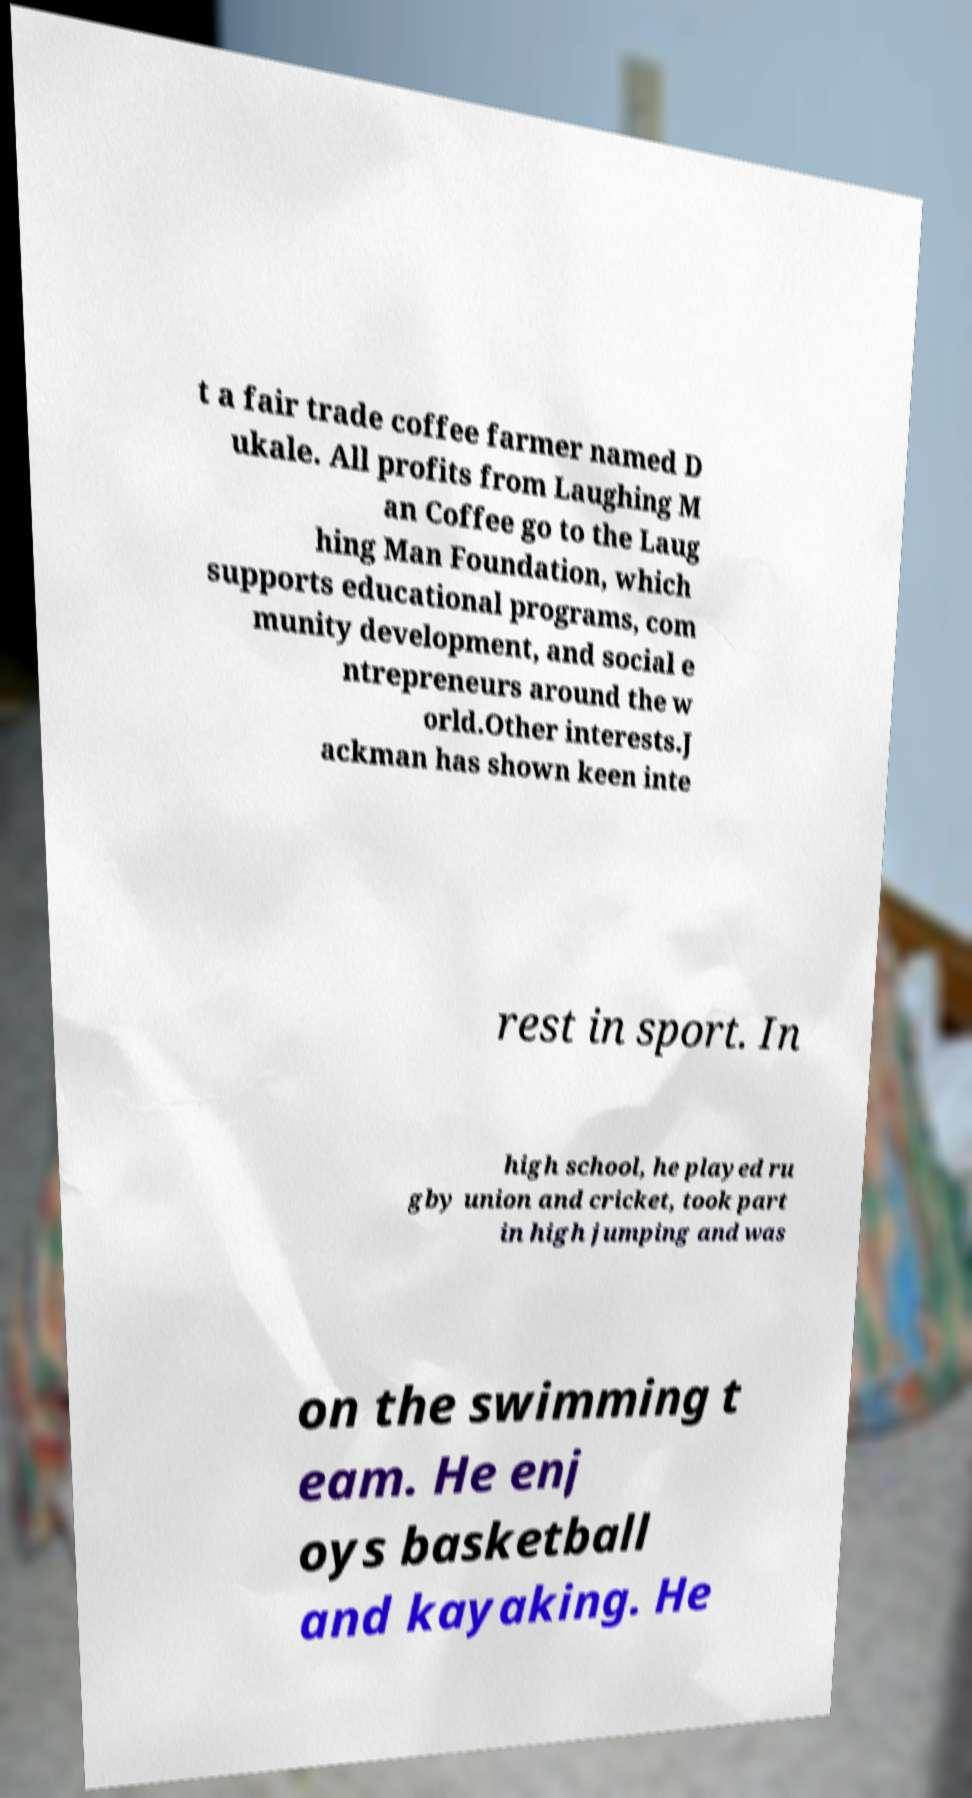I need the written content from this picture converted into text. Can you do that? t a fair trade coffee farmer named D ukale. All profits from Laughing M an Coffee go to the Laug hing Man Foundation, which supports educational programs, com munity development, and social e ntrepreneurs around the w orld.Other interests.J ackman has shown keen inte rest in sport. In high school, he played ru gby union and cricket, took part in high jumping and was on the swimming t eam. He enj oys basketball and kayaking. He 